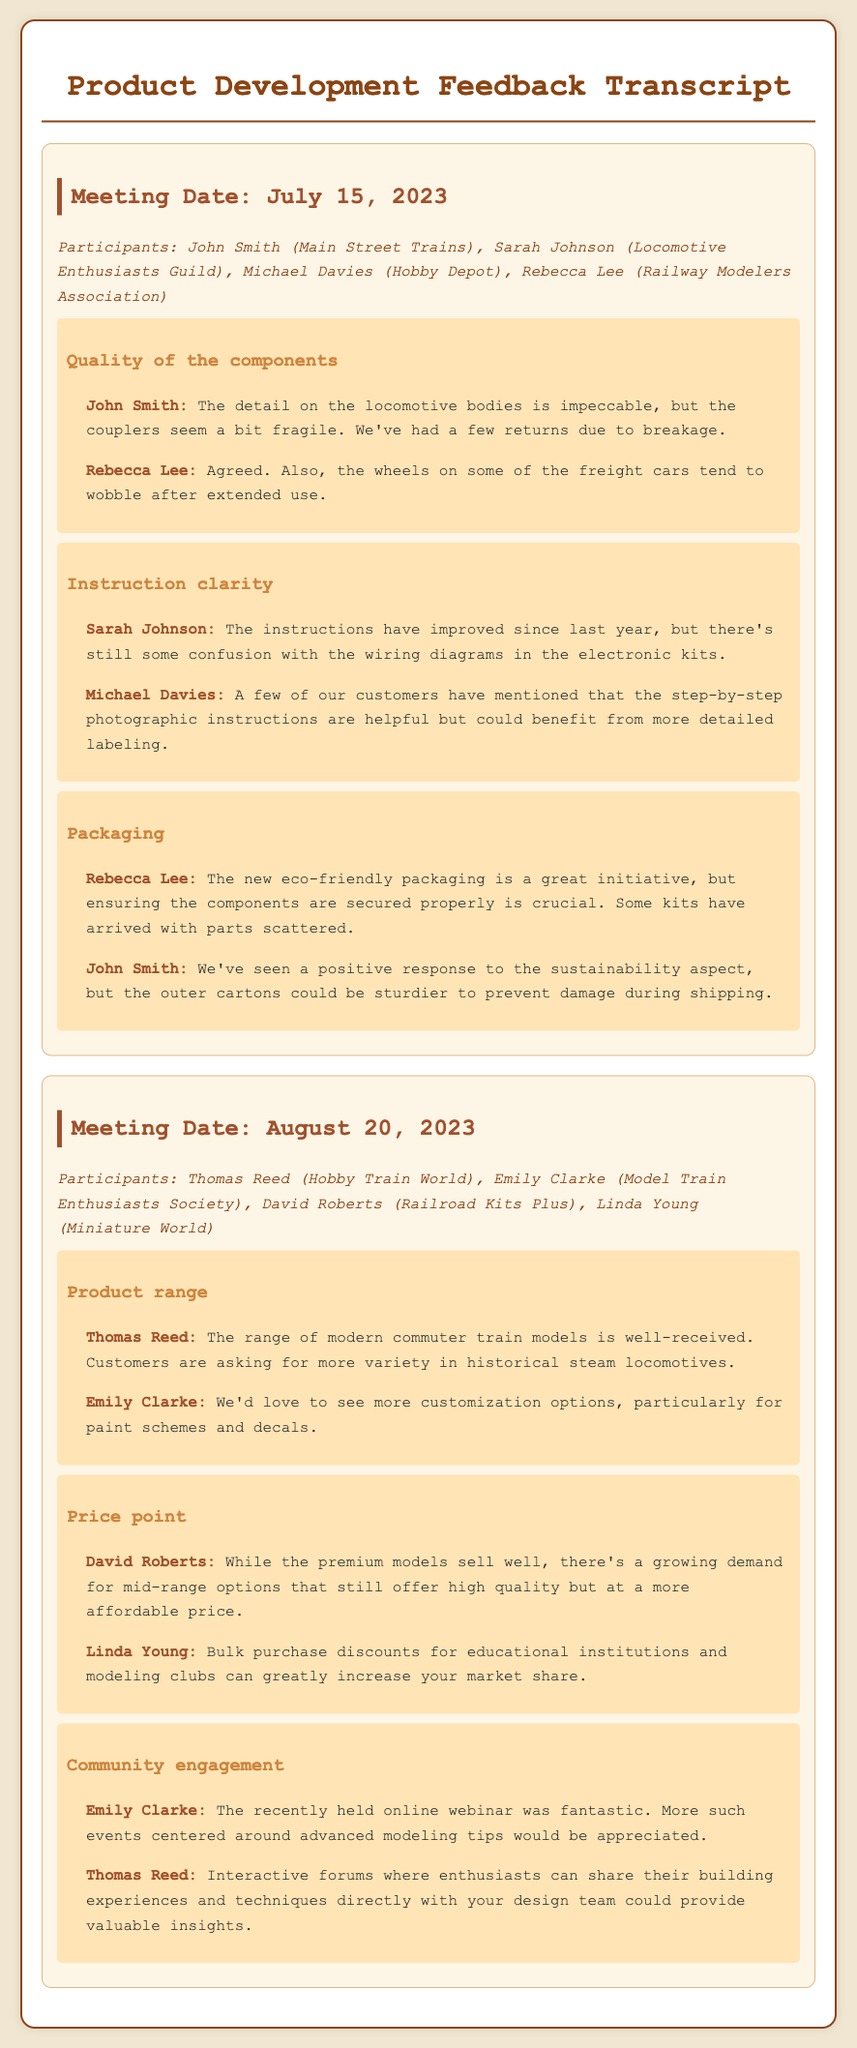What is the date of the first meeting? The first meeting is documented under “Meeting Date: July 15, 2023.”
Answer: July 15, 2023 Who expressed concerns about the detail on locomotive bodies? The feedback indicates that John Smith highlighted the detail on locomotive bodies as impeccable.
Answer: John Smith What aspect of the packaging did Rebecca Lee mention? Rebecca Lee noted that the eco-friendly packaging needs to ensure components are secured properly.
Answer: Secured properly What type of models are customers requesting more of, according to Thomas Reed? Thomas Reed stated that customers are asking for more variety in historical steam locomotives.
Answer: Historical steam locomotives What improvement in instructions did Michael Davies mention? Michael Davies mentioned that the step-by-step photographic instructions could benefit from more detailed labeling.
Answer: More detailed labeling Which participant suggested bulk purchase discounts? Linda Young suggested bulk purchase discounts for educational institutions and modeling clubs.
Answer: Linda Young What theme was discussed in the second meeting regarding community engagement? The theme discussed was around online webinars and interactive forums to engage the community.
Answer: Online webinars and interactive forums How did Sarah Johnson describe the wiring diagrams? Sarah Johnson stated that there is still some confusion with the wiring diagrams in the electronic kits.
Answer: Some confusion What type of feedback did Emily Clarke provide regarding community events? Emily Clarke appreciated the recent online webinar and suggested more events centered around advanced modeling tips.
Answer: More events centered around advanced modeling tips 